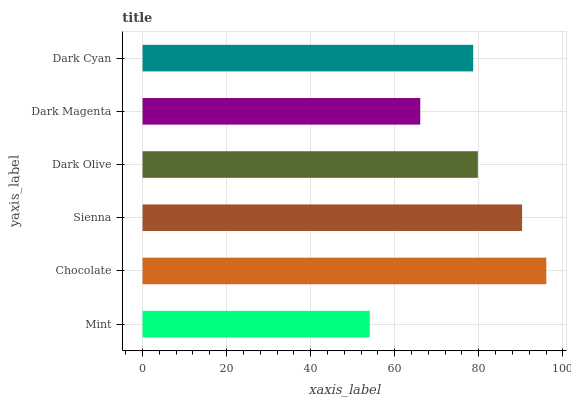Is Mint the minimum?
Answer yes or no. Yes. Is Chocolate the maximum?
Answer yes or no. Yes. Is Sienna the minimum?
Answer yes or no. No. Is Sienna the maximum?
Answer yes or no. No. Is Chocolate greater than Sienna?
Answer yes or no. Yes. Is Sienna less than Chocolate?
Answer yes or no. Yes. Is Sienna greater than Chocolate?
Answer yes or no. No. Is Chocolate less than Sienna?
Answer yes or no. No. Is Dark Olive the high median?
Answer yes or no. Yes. Is Dark Cyan the low median?
Answer yes or no. Yes. Is Dark Cyan the high median?
Answer yes or no. No. Is Sienna the low median?
Answer yes or no. No. 